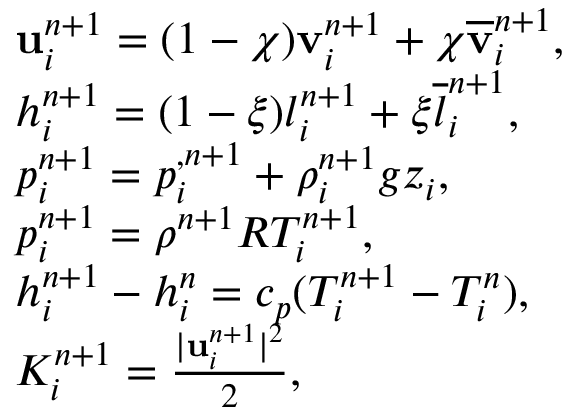Convert formula to latex. <formula><loc_0><loc_0><loc_500><loc_500>\begin{array} { r l } & { \mathbf u _ { i } ^ { n + 1 } = ( 1 - \chi ) { \mathbf v } _ { i } ^ { n + 1 } + \chi \overline { \mathbf v } _ { i } ^ { n + 1 } , } \\ & { h _ { i } ^ { n + 1 } = ( 1 - \xi ) { l } _ { i } ^ { n + 1 } + \xi \overline { l } _ { i } ^ { n + 1 } , } \\ & { p _ { i } ^ { n + 1 } = p _ { i } ^ { , n + 1 } + \rho _ { i } ^ { n + 1 } g z _ { i } , } \\ & { p _ { i } ^ { n + 1 } = \rho ^ { n + 1 } R T _ { i } ^ { n + 1 } , } \\ & { h _ { i } ^ { n + 1 } - h _ { i } ^ { n } = c _ { p } ( T _ { i } ^ { n + 1 } - T _ { i } ^ { n } ) , } \\ & { K _ { i } ^ { n + 1 } = \frac { | \mathbf u _ { i } ^ { n + 1 } | ^ { 2 } } { 2 } , } \end{array}</formula> 